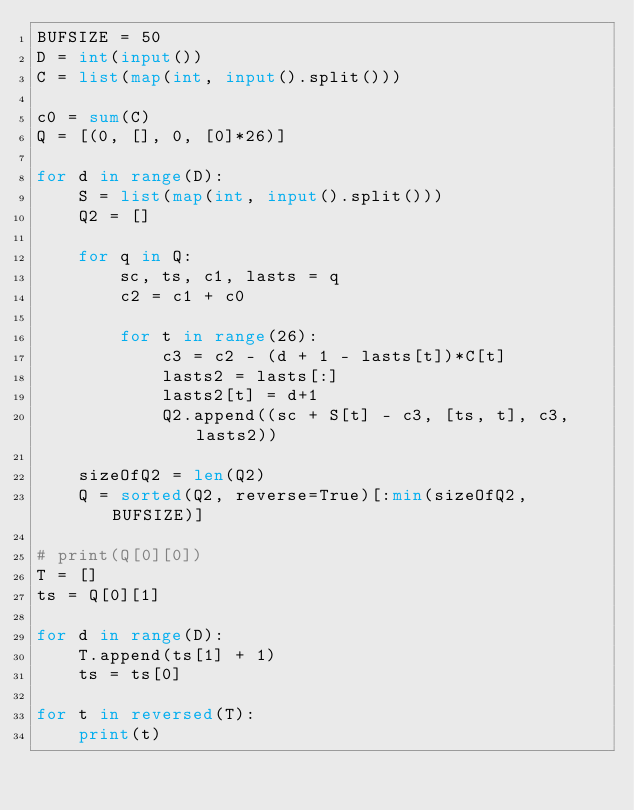<code> <loc_0><loc_0><loc_500><loc_500><_Python_>BUFSIZE = 50
D = int(input())
C = list(map(int, input().split()))

c0 = sum(C)
Q = [(0, [], 0, [0]*26)]

for d in range(D):
    S = list(map(int, input().split()))
    Q2 = []
    
    for q in Q:
        sc, ts, c1, lasts = q
        c2 = c1 + c0

        for t in range(26):
            c3 = c2 - (d + 1 - lasts[t])*C[t]
            lasts2 = lasts[:]
            lasts2[t] = d+1
            Q2.append((sc + S[t] - c3, [ts, t], c3, lasts2))

    sizeOfQ2 = len(Q2)
    Q = sorted(Q2, reverse=True)[:min(sizeOfQ2, BUFSIZE)]

# print(Q[0][0])
T = []
ts = Q[0][1]

for d in range(D):
    T.append(ts[1] + 1)
    ts = ts[0]

for t in reversed(T):
    print(t)

</code> 